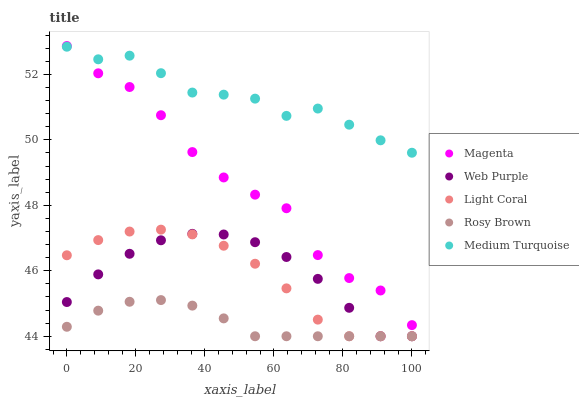Does Rosy Brown have the minimum area under the curve?
Answer yes or no. Yes. Does Medium Turquoise have the maximum area under the curve?
Answer yes or no. Yes. Does Magenta have the minimum area under the curve?
Answer yes or no. No. Does Magenta have the maximum area under the curve?
Answer yes or no. No. Is Rosy Brown the smoothest?
Answer yes or no. Yes. Is Magenta the roughest?
Answer yes or no. Yes. Is Magenta the smoothest?
Answer yes or no. No. Is Rosy Brown the roughest?
Answer yes or no. No. Does Light Coral have the lowest value?
Answer yes or no. Yes. Does Magenta have the lowest value?
Answer yes or no. No. Does Magenta have the highest value?
Answer yes or no. Yes. Does Rosy Brown have the highest value?
Answer yes or no. No. Is Light Coral less than Magenta?
Answer yes or no. Yes. Is Medium Turquoise greater than Rosy Brown?
Answer yes or no. Yes. Does Rosy Brown intersect Light Coral?
Answer yes or no. Yes. Is Rosy Brown less than Light Coral?
Answer yes or no. No. Is Rosy Brown greater than Light Coral?
Answer yes or no. No. Does Light Coral intersect Magenta?
Answer yes or no. No. 